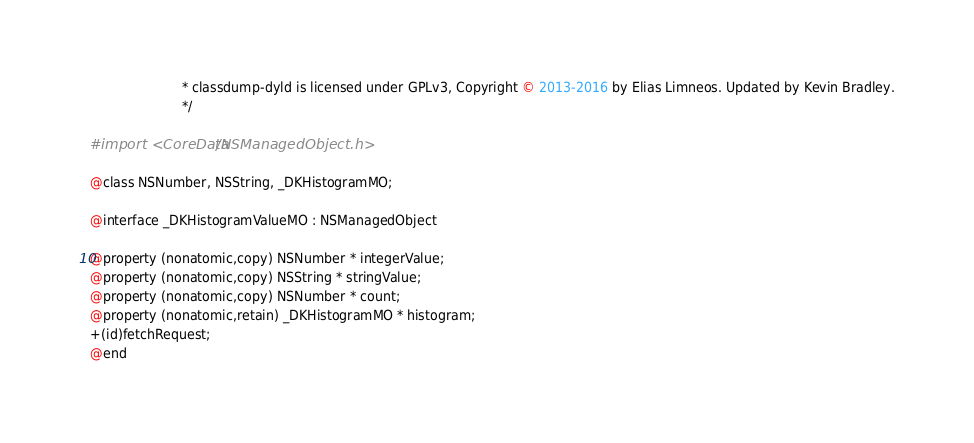<code> <loc_0><loc_0><loc_500><loc_500><_C_>                       * classdump-dyld is licensed under GPLv3, Copyright © 2013-2016 by Elias Limneos. Updated by Kevin Bradley.
                       */

#import <CoreData/NSManagedObject.h>

@class NSNumber, NSString, _DKHistogramMO;

@interface _DKHistogramValueMO : NSManagedObject

@property (nonatomic,copy) NSNumber * integerValue; 
@property (nonatomic,copy) NSString * stringValue; 
@property (nonatomic,copy) NSNumber * count; 
@property (nonatomic,retain) _DKHistogramMO * histogram; 
+(id)fetchRequest;
@end

</code> 